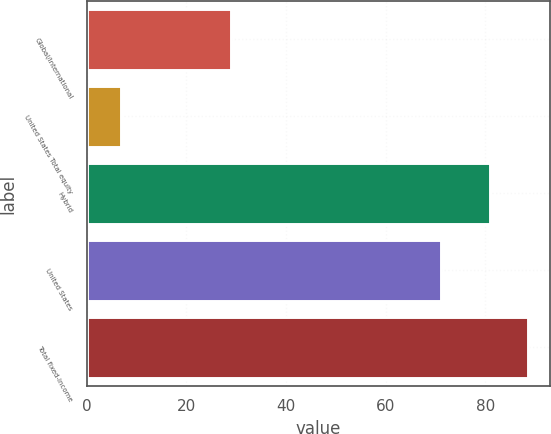Convert chart. <chart><loc_0><loc_0><loc_500><loc_500><bar_chart><fcel>Global/international<fcel>United States Total equity<fcel>Hybrid<fcel>United States<fcel>Total fixed-income<nl><fcel>29<fcel>7<fcel>81<fcel>71<fcel>88.6<nl></chart> 